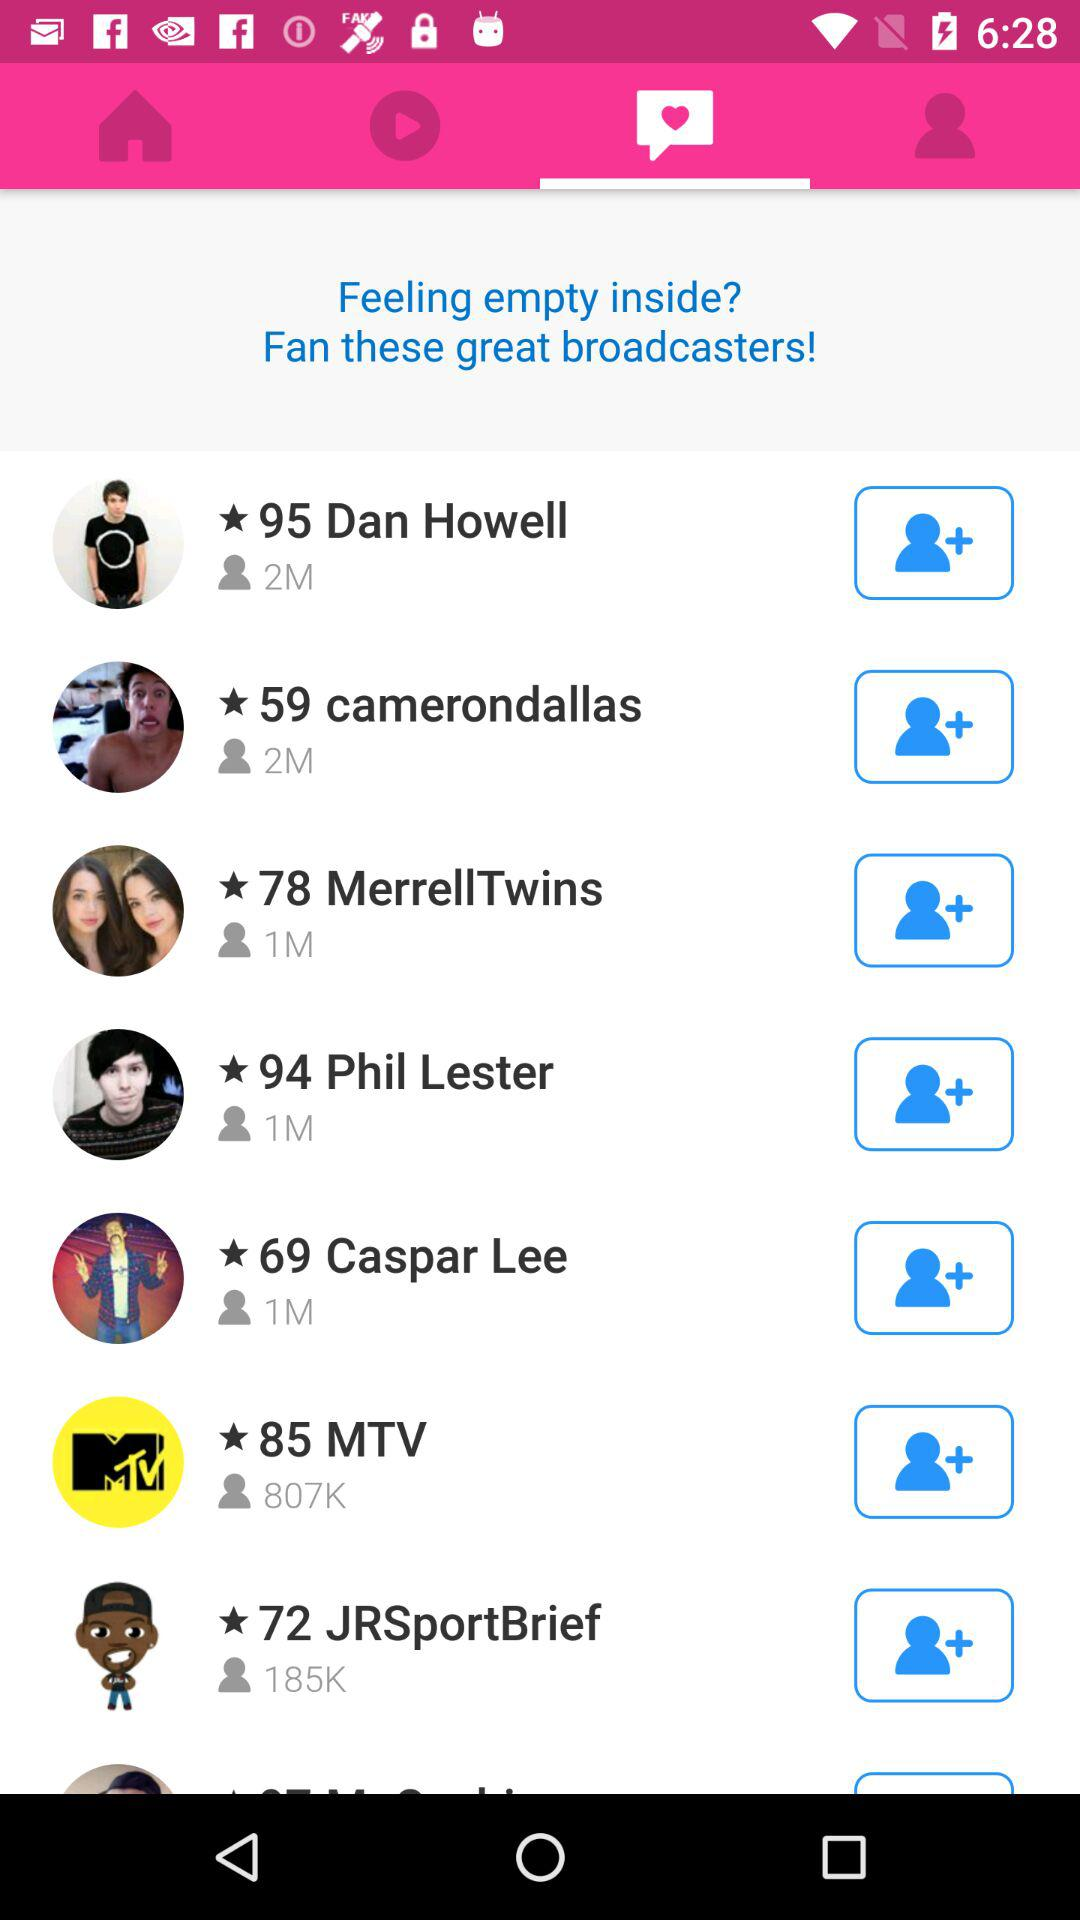Which user has a 185K connection? The user is 72 JRSportBrief. 